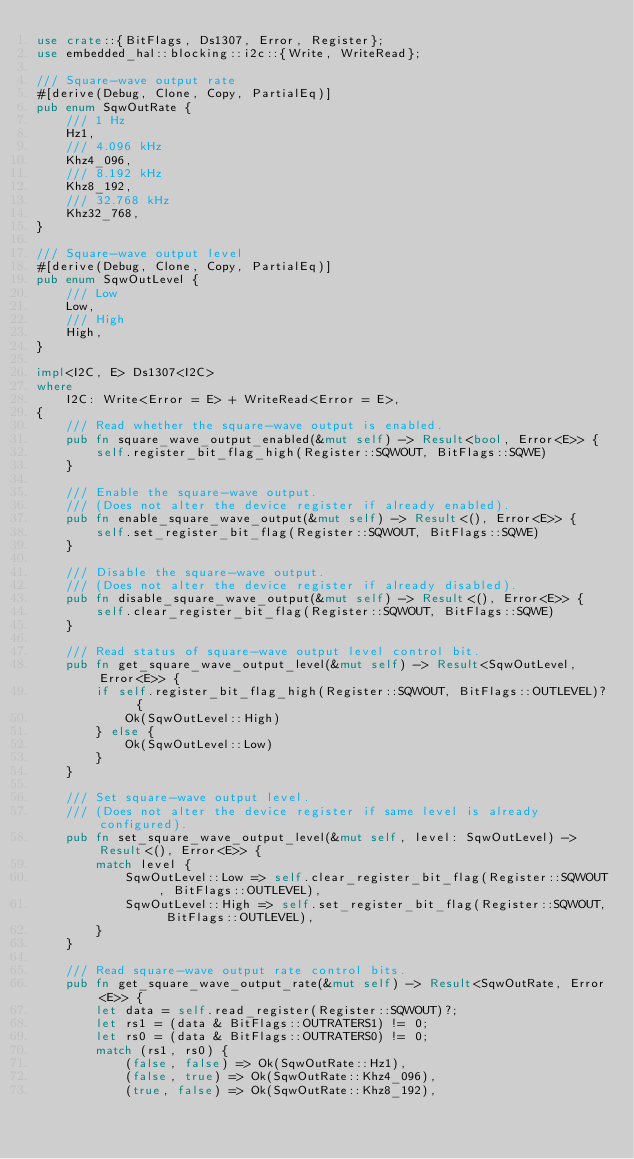<code> <loc_0><loc_0><loc_500><loc_500><_Rust_>use crate::{BitFlags, Ds1307, Error, Register};
use embedded_hal::blocking::i2c::{Write, WriteRead};

/// Square-wave output rate
#[derive(Debug, Clone, Copy, PartialEq)]
pub enum SqwOutRate {
    /// 1 Hz
    Hz1,
    /// 4.096 kHz
    Khz4_096,
    /// 8.192 kHz
    Khz8_192,
    /// 32.768 kHz
    Khz32_768,
}

/// Square-wave output level
#[derive(Debug, Clone, Copy, PartialEq)]
pub enum SqwOutLevel {
    /// Low
    Low,
    /// High
    High,
}

impl<I2C, E> Ds1307<I2C>
where
    I2C: Write<Error = E> + WriteRead<Error = E>,
{
    /// Read whether the square-wave output is enabled.
    pub fn square_wave_output_enabled(&mut self) -> Result<bool, Error<E>> {
        self.register_bit_flag_high(Register::SQWOUT, BitFlags::SQWE)
    }

    /// Enable the square-wave output.
    /// (Does not alter the device register if already enabled).
    pub fn enable_square_wave_output(&mut self) -> Result<(), Error<E>> {
        self.set_register_bit_flag(Register::SQWOUT, BitFlags::SQWE)
    }

    /// Disable the square-wave output.
    /// (Does not alter the device register if already disabled).
    pub fn disable_square_wave_output(&mut self) -> Result<(), Error<E>> {
        self.clear_register_bit_flag(Register::SQWOUT, BitFlags::SQWE)
    }

    /// Read status of square-wave output level control bit.
    pub fn get_square_wave_output_level(&mut self) -> Result<SqwOutLevel, Error<E>> {
        if self.register_bit_flag_high(Register::SQWOUT, BitFlags::OUTLEVEL)? {
            Ok(SqwOutLevel::High)
        } else {
            Ok(SqwOutLevel::Low)
        }
    }

    /// Set square-wave output level.
    /// (Does not alter the device register if same level is already configured).
    pub fn set_square_wave_output_level(&mut self, level: SqwOutLevel) -> Result<(), Error<E>> {
        match level {
            SqwOutLevel::Low => self.clear_register_bit_flag(Register::SQWOUT, BitFlags::OUTLEVEL),
            SqwOutLevel::High => self.set_register_bit_flag(Register::SQWOUT, BitFlags::OUTLEVEL),
        }
    }

    /// Read square-wave output rate control bits.
    pub fn get_square_wave_output_rate(&mut self) -> Result<SqwOutRate, Error<E>> {
        let data = self.read_register(Register::SQWOUT)?;
        let rs1 = (data & BitFlags::OUTRATERS1) != 0;
        let rs0 = (data & BitFlags::OUTRATERS0) != 0;
        match (rs1, rs0) {
            (false, false) => Ok(SqwOutRate::Hz1),
            (false, true) => Ok(SqwOutRate::Khz4_096),
            (true, false) => Ok(SqwOutRate::Khz8_192),</code> 